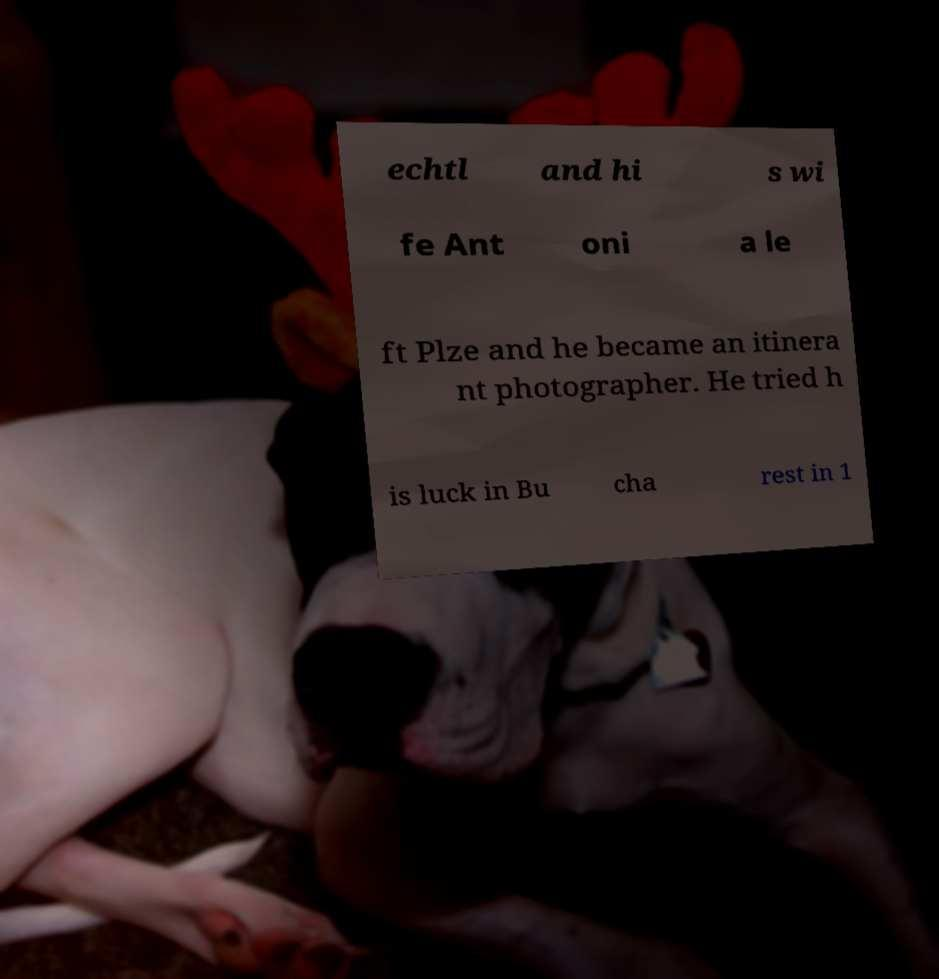There's text embedded in this image that I need extracted. Can you transcribe it verbatim? echtl and hi s wi fe Ant oni a le ft Plze and he became an itinera nt photographer. He tried h is luck in Bu cha rest in 1 